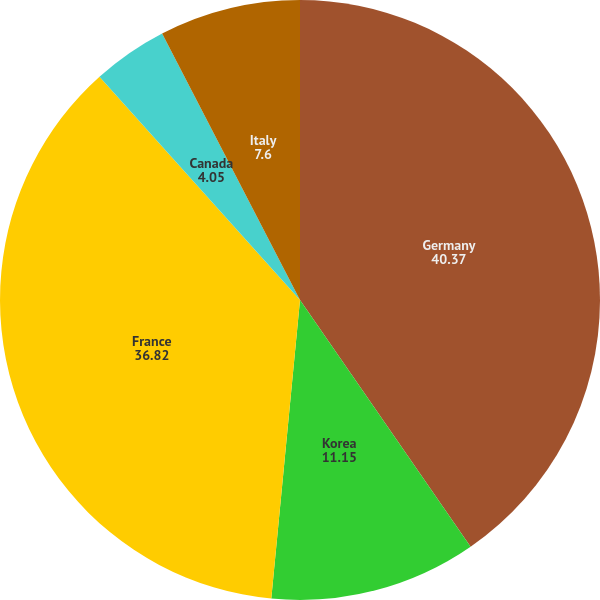Convert chart. <chart><loc_0><loc_0><loc_500><loc_500><pie_chart><fcel>Germany<fcel>Korea<fcel>France<fcel>Canada<fcel>Italy<nl><fcel>40.37%<fcel>11.15%<fcel>36.82%<fcel>4.05%<fcel>7.6%<nl></chart> 